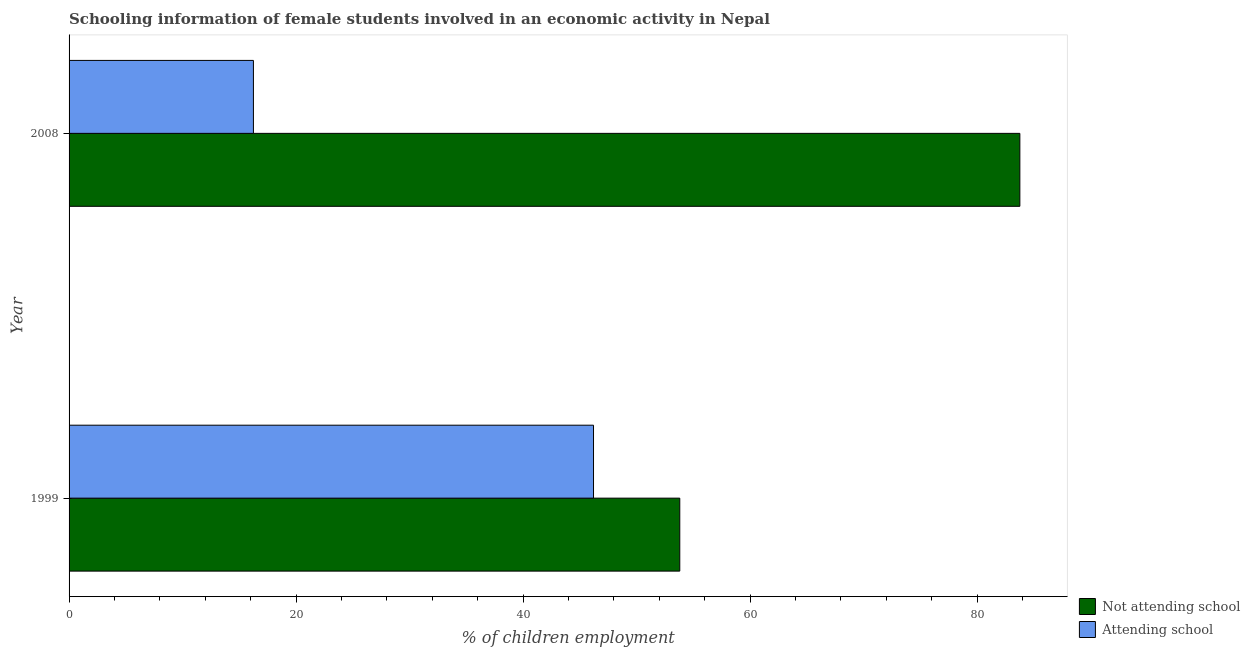How many different coloured bars are there?
Provide a succinct answer. 2. How many groups of bars are there?
Provide a short and direct response. 2. Are the number of bars per tick equal to the number of legend labels?
Your response must be concise. Yes. How many bars are there on the 1st tick from the top?
Provide a short and direct response. 2. What is the label of the 1st group of bars from the top?
Give a very brief answer. 2008. What is the percentage of employed females who are not attending school in 2008?
Give a very brief answer. 83.76. Across all years, what is the maximum percentage of employed females who are attending school?
Your answer should be very brief. 46.2. Across all years, what is the minimum percentage of employed females who are not attending school?
Your response must be concise. 53.8. In which year was the percentage of employed females who are attending school maximum?
Your answer should be very brief. 1999. What is the total percentage of employed females who are not attending school in the graph?
Provide a short and direct response. 137.56. What is the difference between the percentage of employed females who are not attending school in 1999 and that in 2008?
Your response must be concise. -29.96. What is the difference between the percentage of employed females who are attending school in 2008 and the percentage of employed females who are not attending school in 1999?
Give a very brief answer. -37.56. What is the average percentage of employed females who are attending school per year?
Give a very brief answer. 31.22. In the year 2008, what is the difference between the percentage of employed females who are attending school and percentage of employed females who are not attending school?
Your answer should be compact. -67.52. In how many years, is the percentage of employed females who are attending school greater than 68 %?
Give a very brief answer. 0. What is the ratio of the percentage of employed females who are attending school in 1999 to that in 2008?
Provide a short and direct response. 2.85. What does the 2nd bar from the top in 2008 represents?
Offer a very short reply. Not attending school. What does the 2nd bar from the bottom in 2008 represents?
Make the answer very short. Attending school. How many bars are there?
Ensure brevity in your answer.  4. How many years are there in the graph?
Give a very brief answer. 2. What is the difference between two consecutive major ticks on the X-axis?
Offer a terse response. 20. How are the legend labels stacked?
Ensure brevity in your answer.  Vertical. What is the title of the graph?
Offer a terse response. Schooling information of female students involved in an economic activity in Nepal. What is the label or title of the X-axis?
Ensure brevity in your answer.  % of children employment. What is the label or title of the Y-axis?
Offer a terse response. Year. What is the % of children employment of Not attending school in 1999?
Provide a succinct answer. 53.8. What is the % of children employment of Attending school in 1999?
Provide a succinct answer. 46.2. What is the % of children employment in Not attending school in 2008?
Make the answer very short. 83.76. What is the % of children employment in Attending school in 2008?
Keep it short and to the point. 16.24. Across all years, what is the maximum % of children employment in Not attending school?
Give a very brief answer. 83.76. Across all years, what is the maximum % of children employment in Attending school?
Keep it short and to the point. 46.2. Across all years, what is the minimum % of children employment of Not attending school?
Offer a very short reply. 53.8. Across all years, what is the minimum % of children employment in Attending school?
Make the answer very short. 16.24. What is the total % of children employment in Not attending school in the graph?
Your answer should be compact. 137.56. What is the total % of children employment of Attending school in the graph?
Offer a very short reply. 62.44. What is the difference between the % of children employment in Not attending school in 1999 and that in 2008?
Your response must be concise. -29.96. What is the difference between the % of children employment of Attending school in 1999 and that in 2008?
Provide a short and direct response. 29.96. What is the difference between the % of children employment of Not attending school in 1999 and the % of children employment of Attending school in 2008?
Give a very brief answer. 37.56. What is the average % of children employment of Not attending school per year?
Keep it short and to the point. 68.78. What is the average % of children employment of Attending school per year?
Your answer should be compact. 31.22. In the year 1999, what is the difference between the % of children employment of Not attending school and % of children employment of Attending school?
Make the answer very short. 7.6. In the year 2008, what is the difference between the % of children employment in Not attending school and % of children employment in Attending school?
Your response must be concise. 67.52. What is the ratio of the % of children employment of Not attending school in 1999 to that in 2008?
Offer a very short reply. 0.64. What is the ratio of the % of children employment in Attending school in 1999 to that in 2008?
Keep it short and to the point. 2.84. What is the difference between the highest and the second highest % of children employment of Not attending school?
Keep it short and to the point. 29.96. What is the difference between the highest and the second highest % of children employment in Attending school?
Your answer should be compact. 29.96. What is the difference between the highest and the lowest % of children employment of Not attending school?
Provide a short and direct response. 29.96. What is the difference between the highest and the lowest % of children employment in Attending school?
Keep it short and to the point. 29.96. 